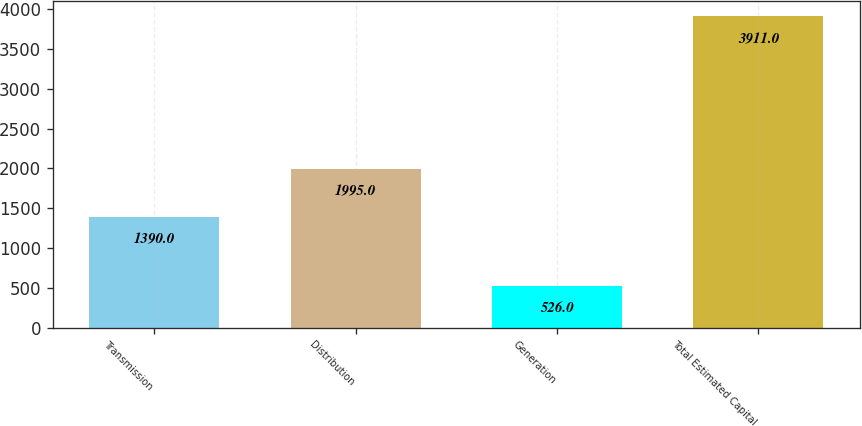<chart> <loc_0><loc_0><loc_500><loc_500><bar_chart><fcel>Transmission<fcel>Distribution<fcel>Generation<fcel>Total Estimated Capital<nl><fcel>1390<fcel>1995<fcel>526<fcel>3911<nl></chart> 